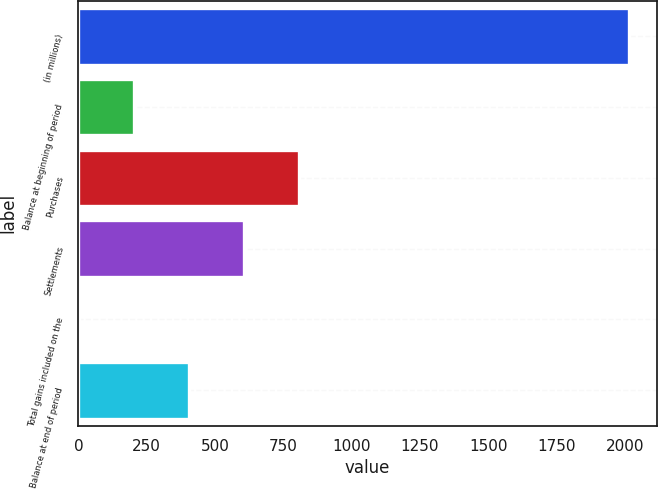<chart> <loc_0><loc_0><loc_500><loc_500><bar_chart><fcel>(in millions)<fcel>Balance at beginning of period<fcel>Purchases<fcel>Settlements<fcel>Total gains included on the<fcel>Balance at end of period<nl><fcel>2017<fcel>203.5<fcel>808<fcel>606.5<fcel>2<fcel>405<nl></chart> 